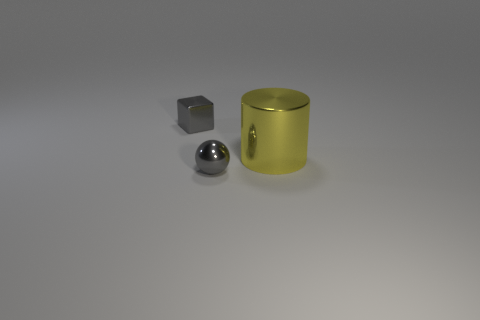Does the small sphere have the same material as the gray cube?
Keep it short and to the point. Yes. What number of objects are in front of the gray metal object that is in front of the small gray metallic object behind the big thing?
Provide a short and direct response. 0. What number of rubber objects are there?
Your response must be concise. 0. Are there fewer large objects that are on the right side of the big yellow metal cylinder than metallic spheres to the left of the tiny cube?
Your response must be concise. No. Are there fewer small gray things that are to the left of the small sphere than small gray shiny things?
Provide a succinct answer. Yes. The yellow object that is to the right of the gray metal thing behind the tiny shiny object that is in front of the yellow metallic cylinder is made of what material?
Keep it short and to the point. Metal. What number of things are gray metal objects in front of the tiny gray block or tiny gray metal things to the right of the gray shiny cube?
Give a very brief answer. 1. How many metal objects are big things or small cubes?
Provide a succinct answer. 2. What shape is the big thing that is the same material as the tiny gray cube?
Offer a terse response. Cylinder. What number of gray things are the same shape as the yellow object?
Ensure brevity in your answer.  0. 